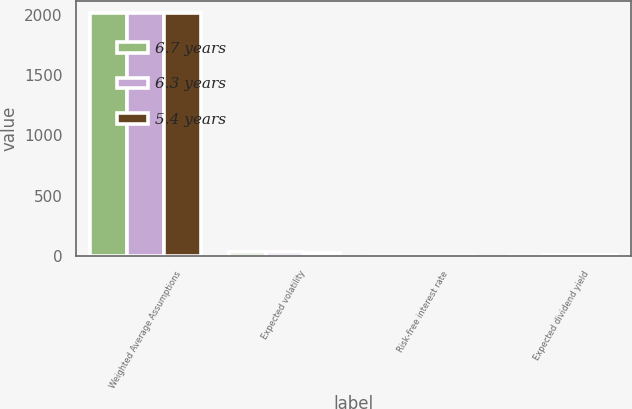<chart> <loc_0><loc_0><loc_500><loc_500><stacked_bar_chart><ecel><fcel>Weighted Average Assumptions<fcel>Expected volatility<fcel>Risk-free interest rate<fcel>Expected dividend yield<nl><fcel>6.7 years<fcel>2013<fcel>33.8<fcel>1.13<fcel>3<nl><fcel>6.3 years<fcel>2014<fcel>34<fcel>2.04<fcel>4<nl><fcel>5.4 years<fcel>2015<fcel>28.4<fcel>1.7<fcel>5<nl></chart> 